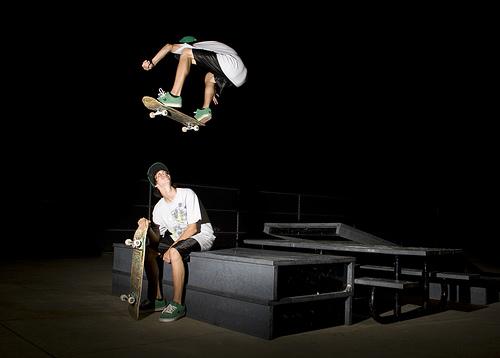What is the man doing?
Quick response, please. Skateboarding. What color are the men's shoes?
Be succinct. Green. Are they outdoors or indoors?
Write a very short answer. Outdoors. Is the guy jumping?
Short answer required. Yes. 